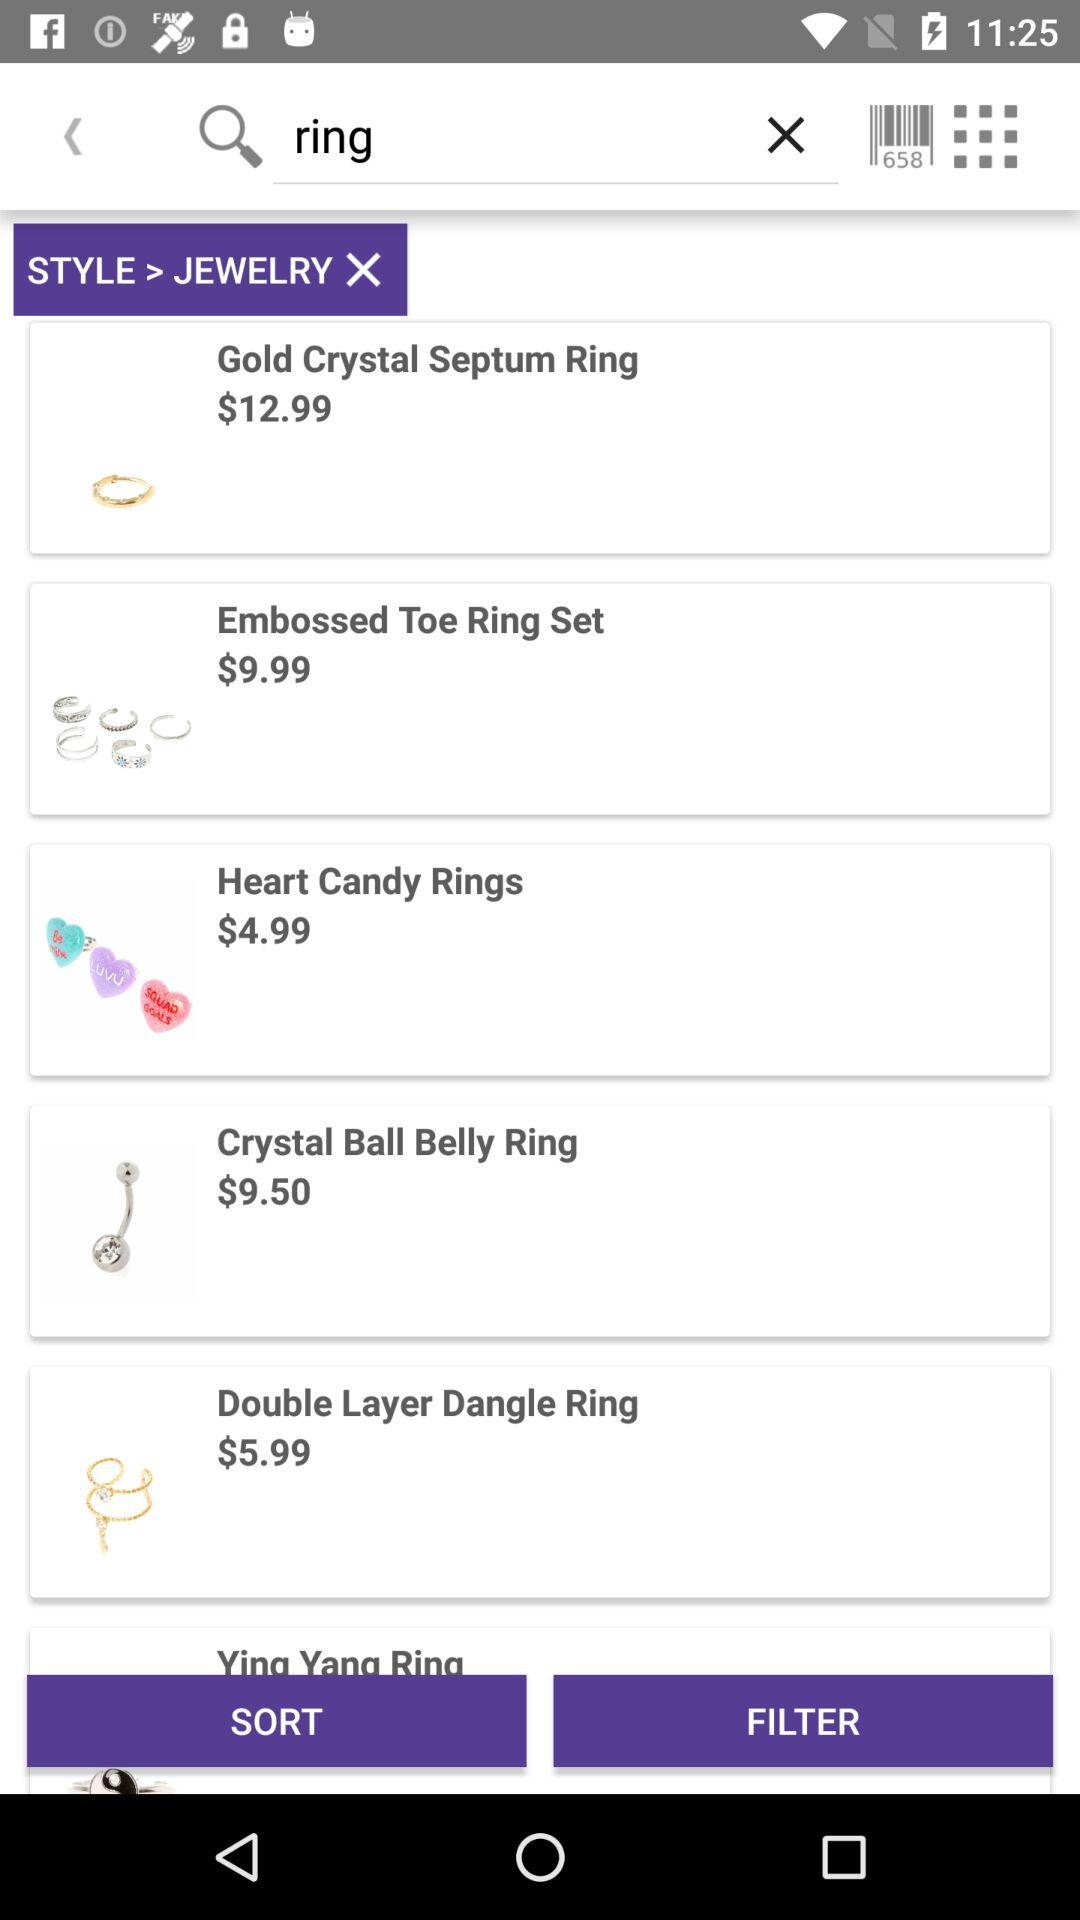What is the price of an embossed toe ring? The price of an embossed toe ring is $9.99. 